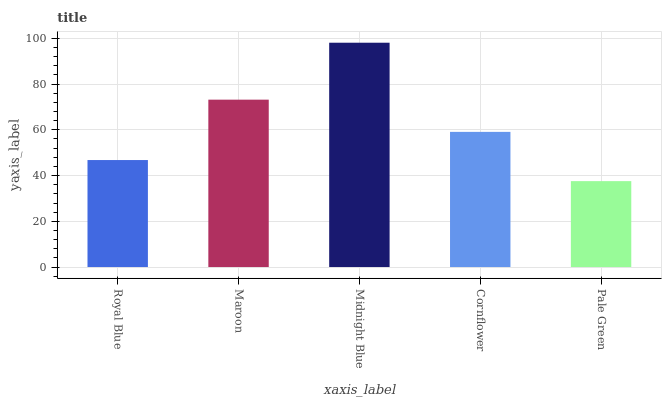Is Pale Green the minimum?
Answer yes or no. Yes. Is Midnight Blue the maximum?
Answer yes or no. Yes. Is Maroon the minimum?
Answer yes or no. No. Is Maroon the maximum?
Answer yes or no. No. Is Maroon greater than Royal Blue?
Answer yes or no. Yes. Is Royal Blue less than Maroon?
Answer yes or no. Yes. Is Royal Blue greater than Maroon?
Answer yes or no. No. Is Maroon less than Royal Blue?
Answer yes or no. No. Is Cornflower the high median?
Answer yes or no. Yes. Is Cornflower the low median?
Answer yes or no. Yes. Is Royal Blue the high median?
Answer yes or no. No. Is Royal Blue the low median?
Answer yes or no. No. 